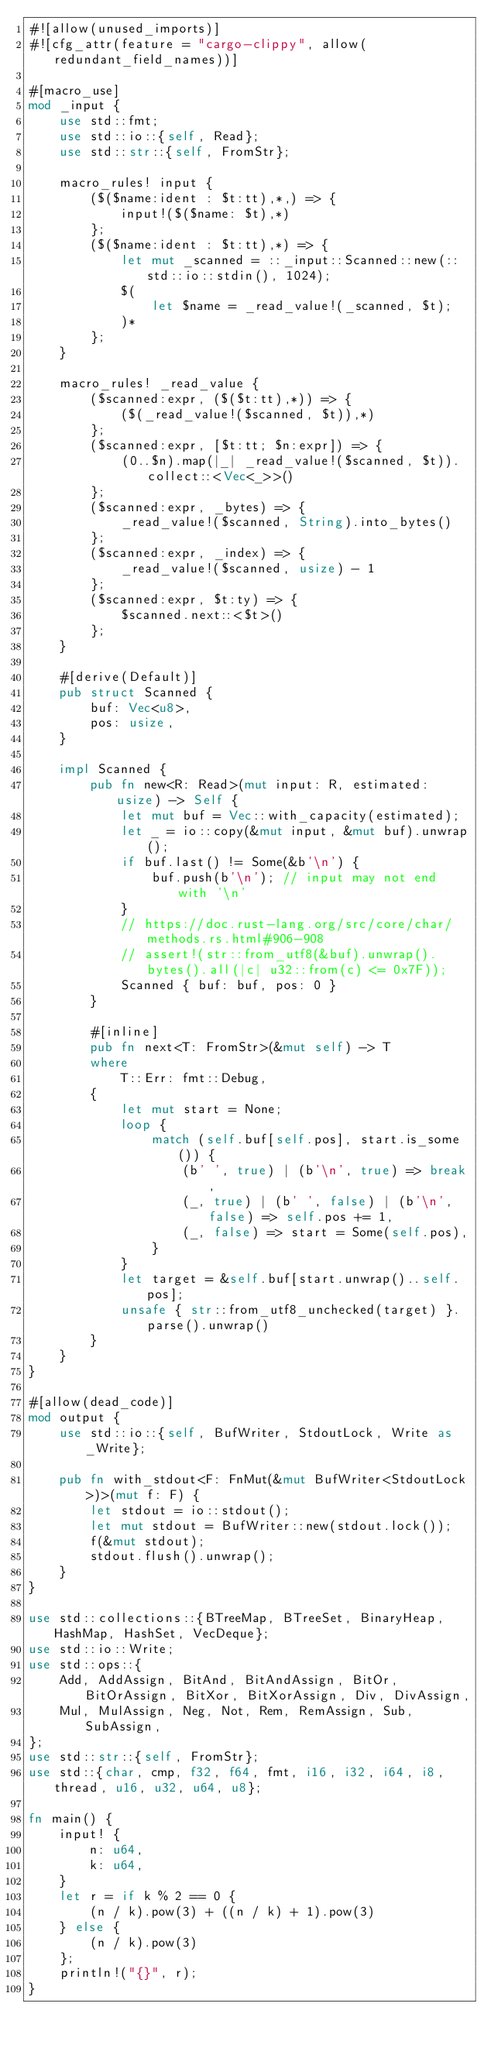Convert code to text. <code><loc_0><loc_0><loc_500><loc_500><_Rust_>#![allow(unused_imports)]
#![cfg_attr(feature = "cargo-clippy", allow(redundant_field_names))]

#[macro_use]
mod _input {
    use std::fmt;
    use std::io::{self, Read};
    use std::str::{self, FromStr};

    macro_rules! input {
        ($($name:ident : $t:tt),*,) => {
            input!($($name: $t),*)
        };
        ($($name:ident : $t:tt),*) => {
            let mut _scanned = ::_input::Scanned::new(::std::io::stdin(), 1024);
            $(
                let $name = _read_value!(_scanned, $t);
            )*
        };
    }

    macro_rules! _read_value {
        ($scanned:expr, ($($t:tt),*)) => {
            ($(_read_value!($scanned, $t)),*)
        };
        ($scanned:expr, [$t:tt; $n:expr]) => {
            (0..$n).map(|_| _read_value!($scanned, $t)).collect::<Vec<_>>()
        };
        ($scanned:expr, _bytes) => {
            _read_value!($scanned, String).into_bytes()
        };
        ($scanned:expr, _index) => {
            _read_value!($scanned, usize) - 1
        };
        ($scanned:expr, $t:ty) => {
            $scanned.next::<$t>()
        };
    }

    #[derive(Default)]
    pub struct Scanned {
        buf: Vec<u8>,
        pos: usize,
    }

    impl Scanned {
        pub fn new<R: Read>(mut input: R, estimated: usize) -> Self {
            let mut buf = Vec::with_capacity(estimated);
            let _ = io::copy(&mut input, &mut buf).unwrap();
            if buf.last() != Some(&b'\n') {
                buf.push(b'\n'); // input may not end with '\n'
            }
            // https://doc.rust-lang.org/src/core/char/methods.rs.html#906-908
            // assert!(str::from_utf8(&buf).unwrap().bytes().all(|c| u32::from(c) <= 0x7F));
            Scanned { buf: buf, pos: 0 }
        }

        #[inline]
        pub fn next<T: FromStr>(&mut self) -> T
        where
            T::Err: fmt::Debug,
        {
            let mut start = None;
            loop {
                match (self.buf[self.pos], start.is_some()) {
                    (b' ', true) | (b'\n', true) => break,
                    (_, true) | (b' ', false) | (b'\n', false) => self.pos += 1,
                    (_, false) => start = Some(self.pos),
                }
            }
            let target = &self.buf[start.unwrap()..self.pos];
            unsafe { str::from_utf8_unchecked(target) }.parse().unwrap()
        }
    }
}

#[allow(dead_code)]
mod output {
    use std::io::{self, BufWriter, StdoutLock, Write as _Write};

    pub fn with_stdout<F: FnMut(&mut BufWriter<StdoutLock>)>(mut f: F) {
        let stdout = io::stdout();
        let mut stdout = BufWriter::new(stdout.lock());
        f(&mut stdout);
        stdout.flush().unwrap();
    }
}

use std::collections::{BTreeMap, BTreeSet, BinaryHeap, HashMap, HashSet, VecDeque};
use std::io::Write;
use std::ops::{
    Add, AddAssign, BitAnd, BitAndAssign, BitOr, BitOrAssign, BitXor, BitXorAssign, Div, DivAssign,
    Mul, MulAssign, Neg, Not, Rem, RemAssign, Sub, SubAssign,
};
use std::str::{self, FromStr};
use std::{char, cmp, f32, f64, fmt, i16, i32, i64, i8, thread, u16, u32, u64, u8};

fn main() {
    input! {
        n: u64,
        k: u64,
    }
    let r = if k % 2 == 0 {
        (n / k).pow(3) + ((n / k) + 1).pow(3)
    } else {
        (n / k).pow(3)
    };
    println!("{}", r);
}
</code> 